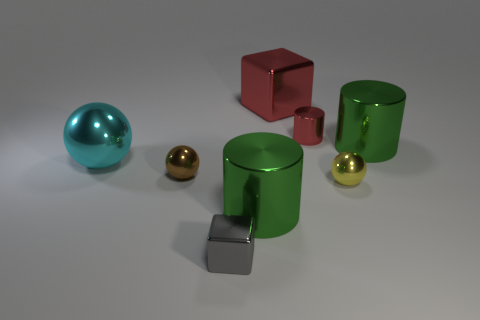Could you describe the shapes and materials of the objects? Certainly! The image features a mix of geometric shapes. We see two cylinders and a cube that appear to be made of a shiny, metallic material; these are colored green and red, respectively. There is also a teal sphere and a golden sphere, both featuring a reflective surface suggesting a metallic composition as well. The smaller gray block at the front has a matte finish, possibly made of a material like stone or plastic. 